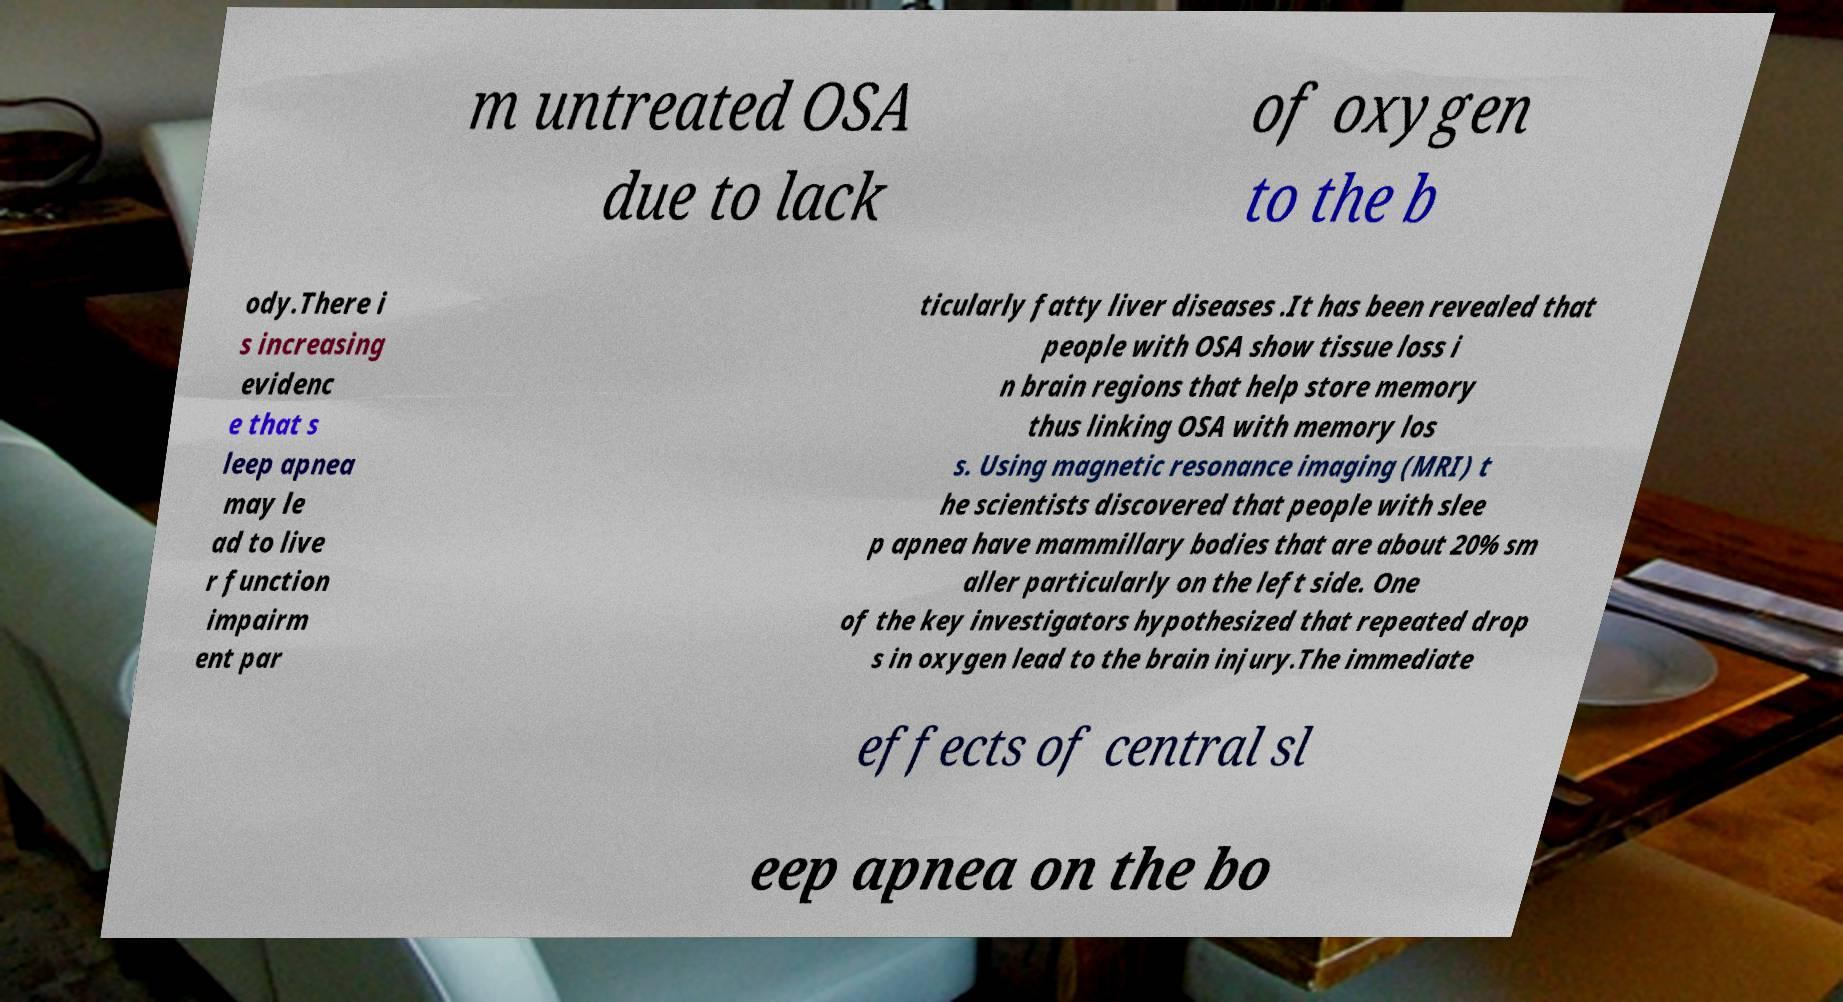Could you extract and type out the text from this image? m untreated OSA due to lack of oxygen to the b ody.There i s increasing evidenc e that s leep apnea may le ad to live r function impairm ent par ticularly fatty liver diseases .It has been revealed that people with OSA show tissue loss i n brain regions that help store memory thus linking OSA with memory los s. Using magnetic resonance imaging (MRI) t he scientists discovered that people with slee p apnea have mammillary bodies that are about 20% sm aller particularly on the left side. One of the key investigators hypothesized that repeated drop s in oxygen lead to the brain injury.The immediate effects of central sl eep apnea on the bo 